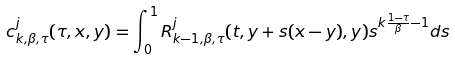<formula> <loc_0><loc_0><loc_500><loc_500>c ^ { j } _ { k , \beta , \tau } ( \tau , x , y ) = \int _ { 0 } ^ { 1 } R ^ { j } _ { k - 1 , \beta , \tau } ( t , y + s ( x - y ) , y ) s ^ { k \frac { 1 - \tau } { \beta } - 1 } d s</formula> 